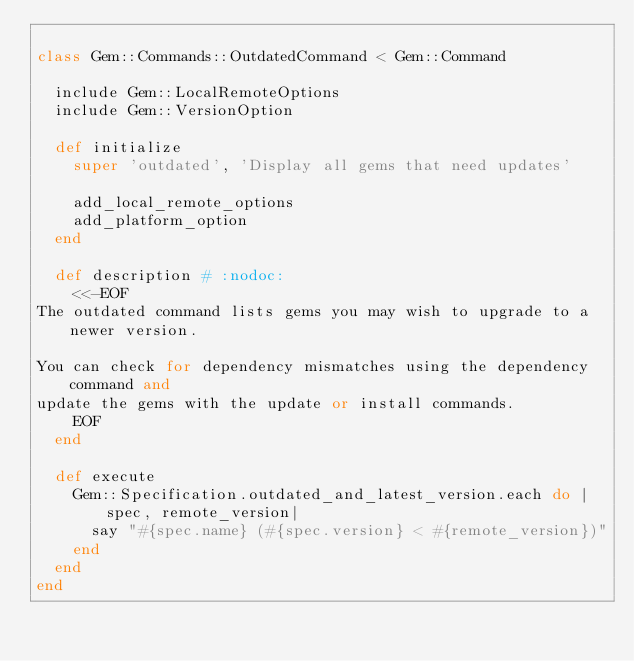Convert code to text. <code><loc_0><loc_0><loc_500><loc_500><_Ruby_>
class Gem::Commands::OutdatedCommand < Gem::Command

  include Gem::LocalRemoteOptions
  include Gem::VersionOption

  def initialize
    super 'outdated', 'Display all gems that need updates'

    add_local_remote_options
    add_platform_option
  end

  def description # :nodoc:
    <<-EOF
The outdated command lists gems you may wish to upgrade to a newer version.

You can check for dependency mismatches using the dependency command and
update the gems with the update or install commands.
    EOF
  end

  def execute
    Gem::Specification.outdated_and_latest_version.each do |spec, remote_version|
      say "#{spec.name} (#{spec.version} < #{remote_version})"
    end
  end
end
</code> 